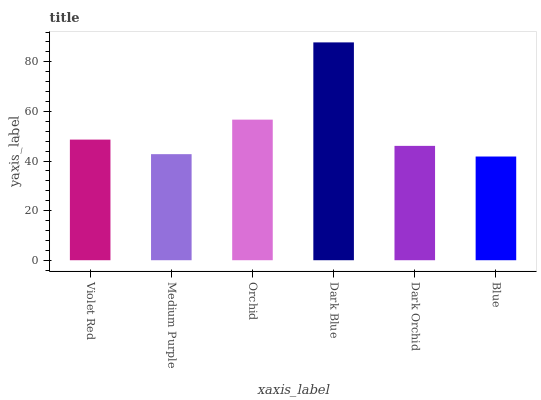Is Blue the minimum?
Answer yes or no. Yes. Is Dark Blue the maximum?
Answer yes or no. Yes. Is Medium Purple the minimum?
Answer yes or no. No. Is Medium Purple the maximum?
Answer yes or no. No. Is Violet Red greater than Medium Purple?
Answer yes or no. Yes. Is Medium Purple less than Violet Red?
Answer yes or no. Yes. Is Medium Purple greater than Violet Red?
Answer yes or no. No. Is Violet Red less than Medium Purple?
Answer yes or no. No. Is Violet Red the high median?
Answer yes or no. Yes. Is Dark Orchid the low median?
Answer yes or no. Yes. Is Blue the high median?
Answer yes or no. No. Is Orchid the low median?
Answer yes or no. No. 